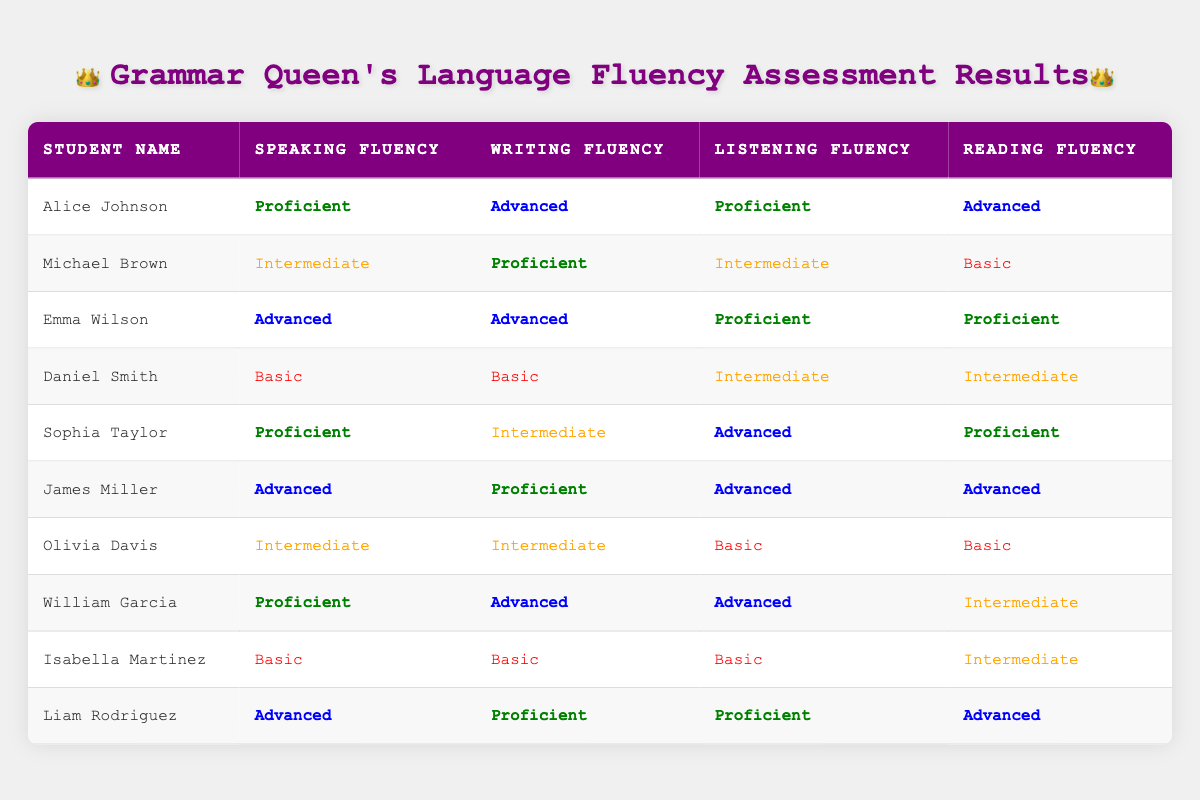What is the speaking fluency level of Emma Wilson? The table indicates that Emma Wilson's speaking fluency is listed as "Advanced."
Answer: Advanced How many students have "Basic" as their reading fluency? By examining the table, I can see that both Daniel Smith and Isabella Martinez have "Basic" as their reading fluency, which gives a total of 2 students.
Answer: 2 Which student has the highest levels of fluency in all categories? James Miller displays "Advanced" in speaking, listening, reading, and "Proficient" in writing, which are all high levels; hence, he has the highest overall fluency ratings.
Answer: James Miller Are there any students with "Intermediate" in all fluency categories? Searching through the table shows that there is no single student listed with "Intermediate" fluency across all four categories — students have varying levels in different areas.
Answer: No What is the average speaking fluency level for the students? To determine the average, I assign numerical values: Advanced (3), Proficient (2), Intermediate (1), Basic (0). Summing the values of each student gives (2 + 1 + 3 + 0 + 2 + 3 + 1 + 2 + 0 + 3) = 17. Since there are 10 students, the average is 17/10 = 1.7, which corresponds to the level between Proficient and Intermediate, closer to Proficient.
Answer: Approximately Proficient Which student(s) have "Advanced" listening fluency? A review of the table shows that both Emma Wilson, James Miller, and Liam Rodriguez achieved "Advanced" in listening fluency upon checking the listening fluency column.
Answer: Emma Wilson, James Miller, Liam Rodriguez Is there a student who has the same level for both writing and reading fluency? By examining the table closely, I find that William Garcia and Sophia Taylor both have "Advanced" for writing and different levels for reading, indicating no match; meanwhile Michael Brown has "Proficient" for writing and "Basic" for reading, leading to no exact matches.
Answer: No How many students scored “Proficient” or higher in both speaking and reading fluency? Checking the table reveals that Alice Johnson, Emma Wilson, William Garcia, and Liam Rodriguez achieved “Proficient” or higher in both speaking and reading fluency, totaling 4 students.
Answer: 4 